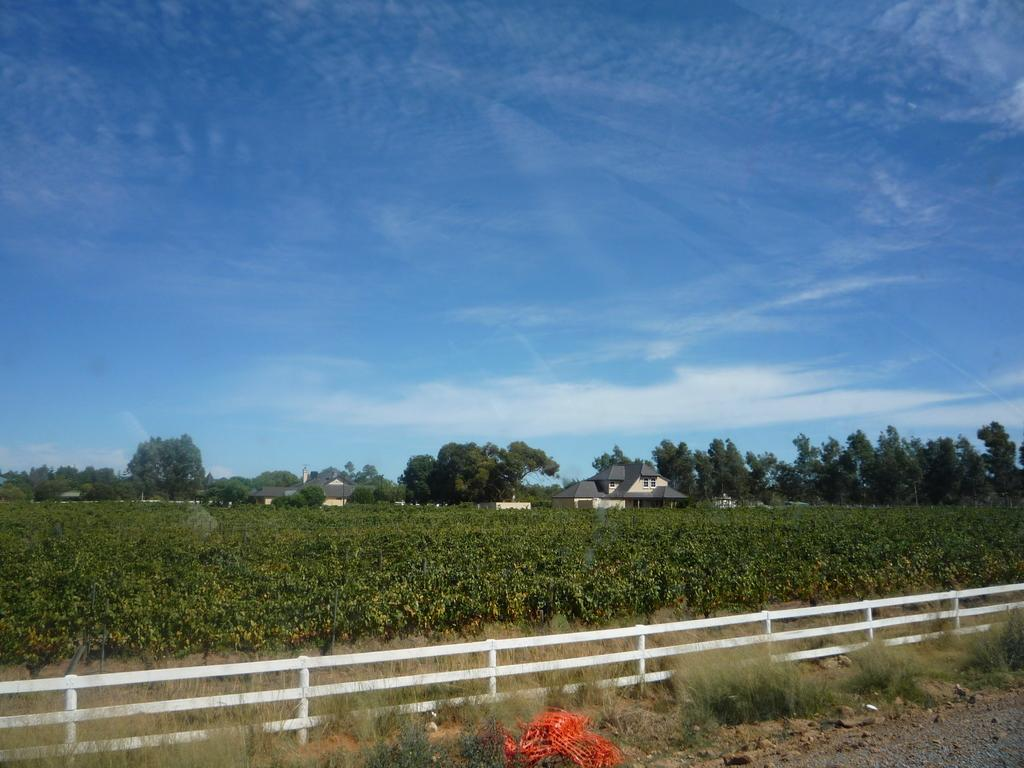What type of structure can be seen in the image? There is a fence in the image. What other natural elements are present in the image? There are plants and trees in the image. What type of man-made structures can be seen in the image? There are houses in the image. What is visible behind the trees in the image? The sky is visible behind the trees in the image. Can you tell me who won the argument that took place on the sofa in the image? There is no argument or sofa present in the image. What emotion can be seen on the faces of the people in the image? There are no people present in the image, so it is impossible to determine their emotions. 